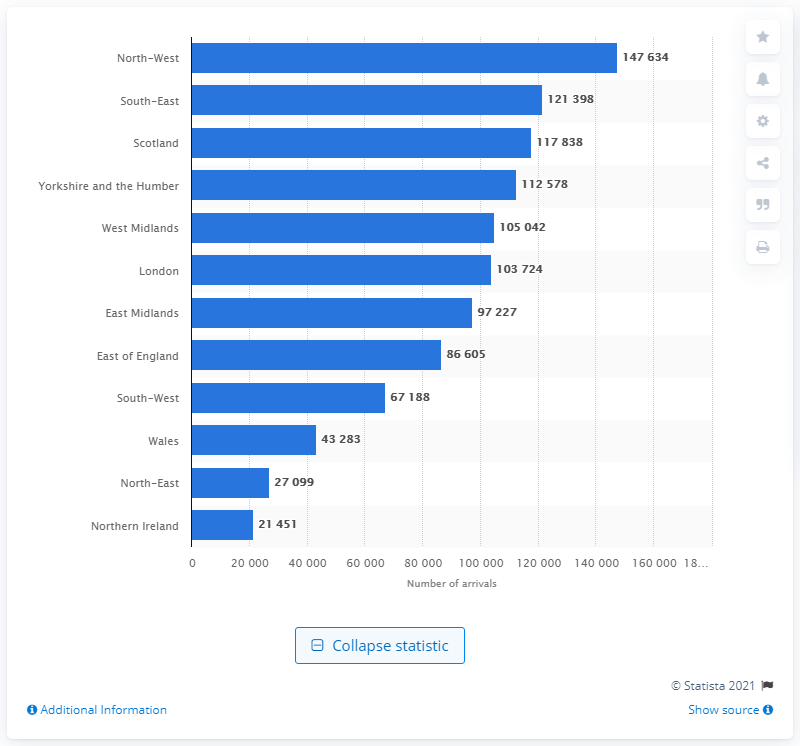Draw attention to some important aspects in this diagram. The smallest number of tourists arrived from Northern Ireland. 